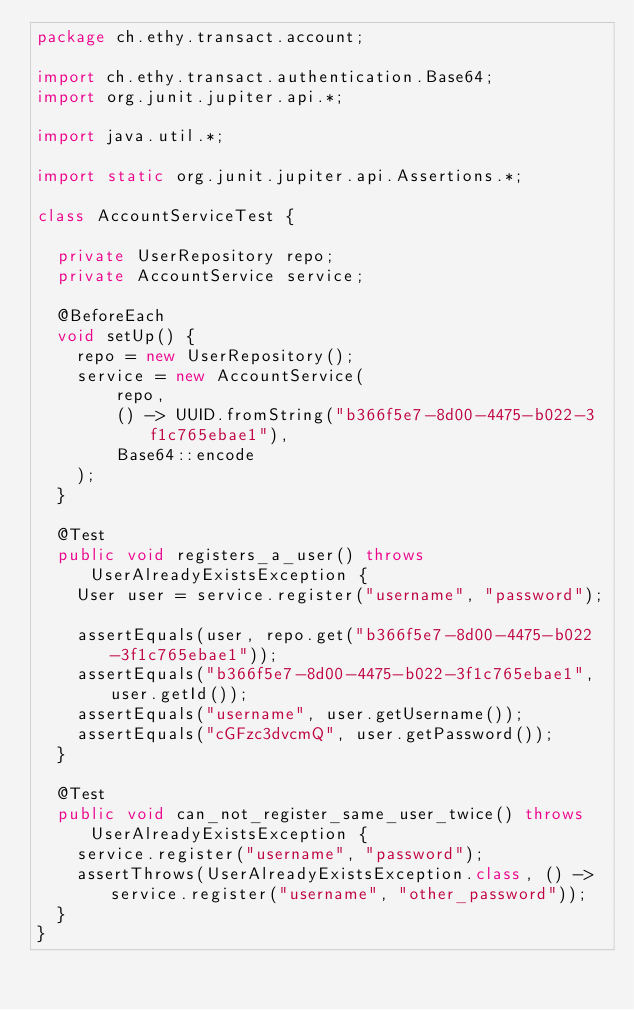<code> <loc_0><loc_0><loc_500><loc_500><_Java_>package ch.ethy.transact.account;

import ch.ethy.transact.authentication.Base64;
import org.junit.jupiter.api.*;

import java.util.*;

import static org.junit.jupiter.api.Assertions.*;

class AccountServiceTest {

  private UserRepository repo;
  private AccountService service;

  @BeforeEach
  void setUp() {
    repo = new UserRepository();
    service = new AccountService(
        repo,
        () -> UUID.fromString("b366f5e7-8d00-4475-b022-3f1c765ebae1"),
        Base64::encode
    );
  }

  @Test
  public void registers_a_user() throws UserAlreadyExistsException {
    User user = service.register("username", "password");

    assertEquals(user, repo.get("b366f5e7-8d00-4475-b022-3f1c765ebae1"));
    assertEquals("b366f5e7-8d00-4475-b022-3f1c765ebae1", user.getId());
    assertEquals("username", user.getUsername());
    assertEquals("cGFzc3dvcmQ", user.getPassword());
  }

  @Test
  public void can_not_register_same_user_twice() throws UserAlreadyExistsException {
    service.register("username", "password");
    assertThrows(UserAlreadyExistsException.class, () -> service.register("username", "other_password"));
  }
}</code> 